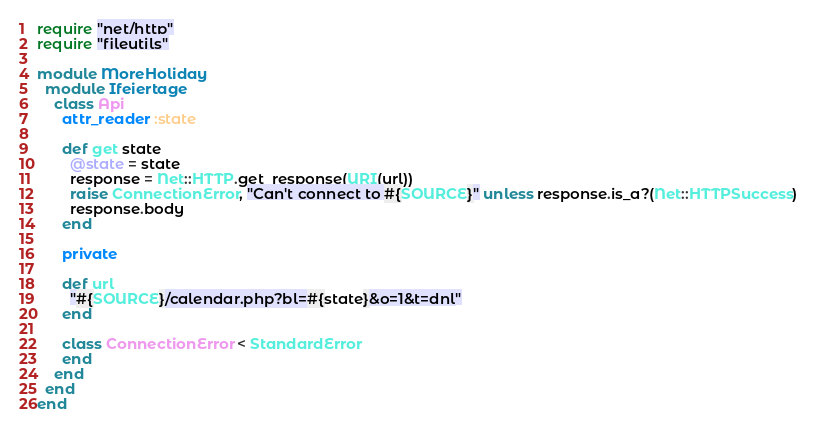Convert code to text. <code><loc_0><loc_0><loc_500><loc_500><_Ruby_>require "net/http"
require "fileutils"

module MoreHoliday
  module Ifeiertage
    class Api
      attr_reader :state

      def get state
        @state = state
        response = Net::HTTP.get_response(URI(url))
        raise ConnectionError, "Can't connect to #{SOURCE}" unless response.is_a?(Net::HTTPSuccess)
        response.body
      end

      private

      def url
        "#{SOURCE}/calendar.php?bl=#{state}&o=1&t=dnl"
      end

      class ConnectionError < StandardError
      end
    end
  end
end
</code> 